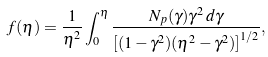Convert formula to latex. <formula><loc_0><loc_0><loc_500><loc_500>f ( \eta ) = \frac { 1 } { \eta ^ { 2 } } \int _ { 0 } ^ { \eta } \frac { N _ { p } ( \gamma ) \gamma ^ { 2 } \, d \gamma } { \left [ ( 1 - \gamma ^ { 2 } ) ( \eta ^ { 2 } - \gamma ^ { 2 } ) \right ] ^ { 1 / 2 } } ,</formula> 